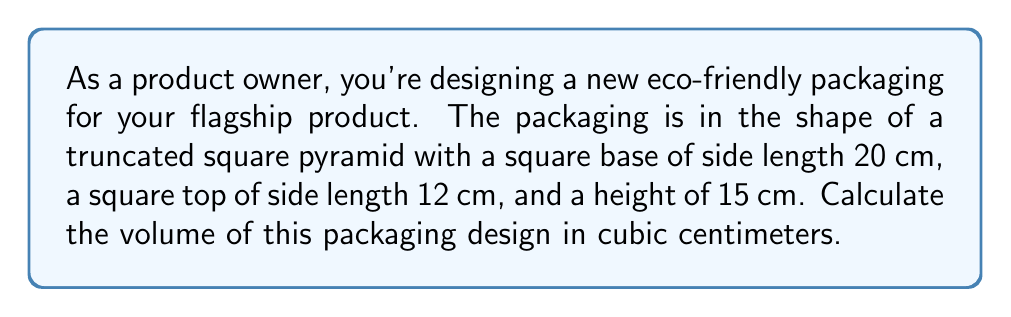Provide a solution to this math problem. To calculate the volume of a truncated square pyramid, we can use the following formula:

$$V = \frac{1}{3}h(a^2 + ab + b^2)$$

Where:
$V$ = volume
$h$ = height of the truncated pyramid
$a$ = side length of the larger square (base)
$b$ = side length of the smaller square (top)

Given:
$h = 15$ cm
$a = 20$ cm
$b = 12$ cm

Let's substitute these values into the formula:

$$\begin{align*}
V &= \frac{1}{3} \times 15 \times (20^2 + 20 \times 12 + 12^2) \\[6pt]
&= 5 \times (400 + 240 + 144) \\[6pt]
&= 5 \times 784 \\[6pt]
&= 3920
\end{align*}$$

Therefore, the volume of the packaging is 3920 cubic centimeters.

[asy]
import three;

size(200);
currentprojection=perspective(6,3,2);

// Define points
pair A1=(0,0), B1=(20,0), C1=(20,20), D1=(0,20);
pair A2=(4,4), B2=(16,4), C2=(16,16), D2=(4,16);

// Draw base
draw(A1--B1--C1--D1--cycle);

// Draw top
draw(A2--B2--C2--D2--cycle);

// Draw edges
draw(A1--A2);
draw(B1--B2);
draw(C1--C2);
draw(D1--D2);

// Label dimensions
label("20 cm", (10,0), S);
label("12 cm", (10,10), N);
label("15 cm", (0,10), W);

[/asy]
Answer: 3920 cm³ 